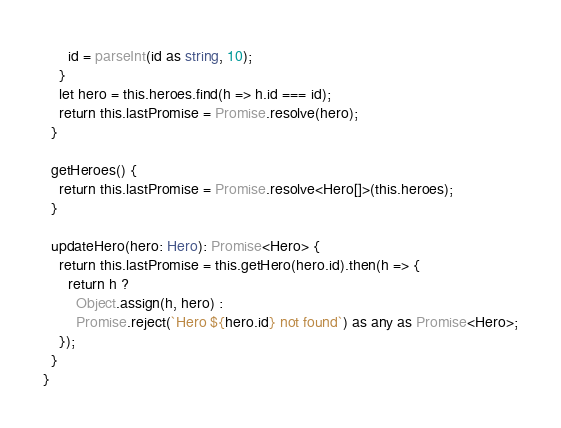<code> <loc_0><loc_0><loc_500><loc_500><_TypeScript_>      id = parseInt(id as string, 10);
    }
    let hero = this.heroes.find(h => h.id === id);
    return this.lastPromise = Promise.resolve(hero);
  }

  getHeroes() {
    return this.lastPromise = Promise.resolve<Hero[]>(this.heroes);
  }

  updateHero(hero: Hero): Promise<Hero> {
    return this.lastPromise = this.getHero(hero.id).then(h => {
      return h ?
        Object.assign(h, hero) :
        Promise.reject(`Hero ${hero.id} not found`) as any as Promise<Hero>;
    });
  }
}
</code> 